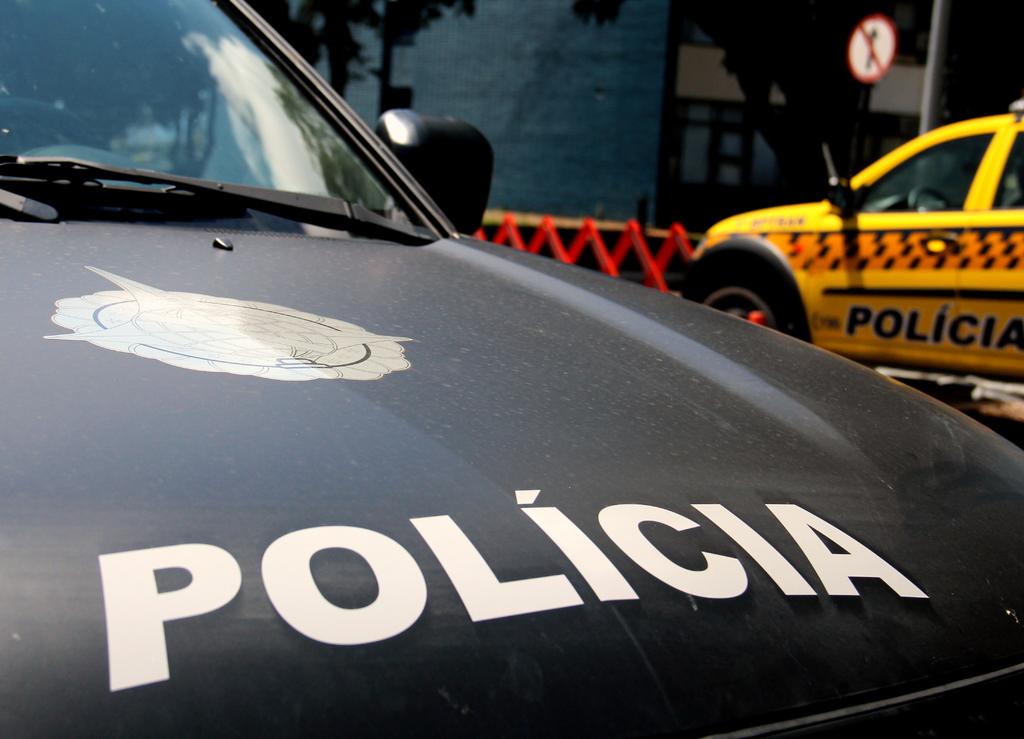What type of car is being shown here?
Provide a short and direct response. Policia. What type of car is the yellow car in the back?
Give a very brief answer. Policia. 